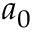Convert formula to latex. <formula><loc_0><loc_0><loc_500><loc_500>a _ { 0 }</formula> 